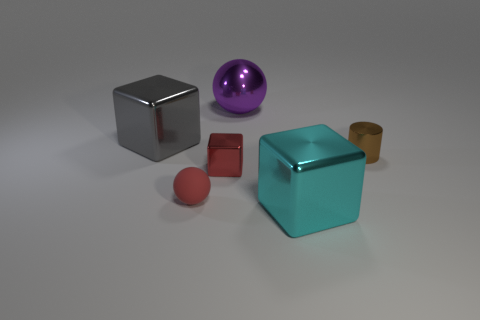Add 1 gray shiny things. How many objects exist? 7 Add 5 purple shiny spheres. How many purple shiny spheres are left? 6 Add 6 red blocks. How many red blocks exist? 7 Subtract 0 purple cubes. How many objects are left? 6 Subtract all balls. How many objects are left? 4 Subtract all large gray metal blocks. Subtract all yellow metal balls. How many objects are left? 5 